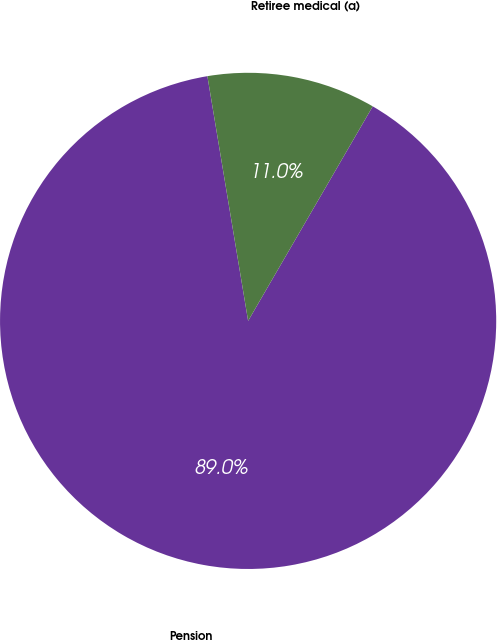<chart> <loc_0><loc_0><loc_500><loc_500><pie_chart><fcel>Pension<fcel>Retiree medical (a)<nl><fcel>89.0%<fcel>11.0%<nl></chart> 